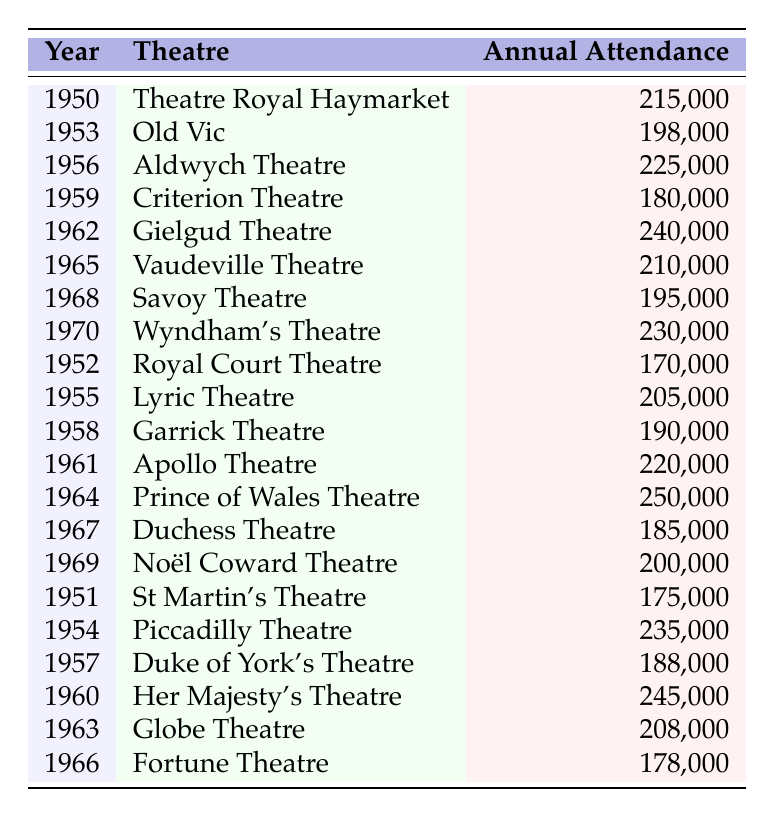What was the highest annual attendance recorded in the table? The highest annual attendance can be found by scanning through the values listed in the "Annual Attendance" column. The maximum value is 250,000 recorded for the Prince of Wales Theatre in 1964.
Answer: 250,000 In which year did the Aldwych Theatre have an annual attendance of 225,000? From the table, we can locate the entry for Aldwych Theatre and find that the annual attendance of 225,000 occurred in the year 1956.
Answer: 1956 What is the average annual attendance for the theaters listed in the table? First, we sum all the annual attendance figures: 215000 + 198000 + 225000 + 180000 + 240000 + 210000 + 195000 + 230000 + 170000 + 205000 + 190000 + 220000 + 250000 + 185000 + 200000 + 175000 + 235000 + 188000 + 245000 + 208000 + 178000 = 3,925,000. Next, we count the number of entries, which is 21. Finally, we divide the sum by the number of entries: 3,925,000 / 21 ≈ 186,904.76, rounding this gives approximately 186,905.
Answer: 186,905 Did the Royal Court Theatre have a higher attendance than the Lyric Theatre? We can compare their respective attendance figures: Royal Court Theatre had an attendance of 170,000, and the Lyric Theatre had 205,000. Since 170,000 is less than 205,000, the statement is false.
Answer: No Which theater had the lowest attendance in 1959? Checking the data for 1959, the Criterion Theatre had an attendance of 180,000, which is the only entry for that year, making it the lowest attendance figure in 1959.
Answer: Criterion Theatre What was the difference in annual attendance between the Gielgud Theatre and the Duchess Theatre? The Gielgud Theatre had an attendance of 240,000 and the Duchess Theatre had 185,000. To find the difference, subtract the lower figure from the higher: 240,000 - 185,000 = 55,000.
Answer: 55,000 Which years between 1950 and 1970 had an attendance figure greater than 200,000? We need to go through each entry from the table and identify those with attendance figures over 200,000. The valid years are 1956 (225,000), 1960 (245,000), 1961 (220,000), 1962 (240,000), 1964 (250,000), 1965 (210,000), 1970 (230,000).
Answer: 1956, 1960, 1961, 1962, 1964, 1965, 1970 How many theaters had an attendance below 190,000? By examining the attendance values, we find the following theaters below 190,000: Royal Court Theatre (170,000), St Martin's Theatre (175,000), Fortune Theatre (178,000), Duchess Theatre (185,000), and Criterion Theatre (180,000), totaling 5 theaters.
Answer: 5 Was the attendance for the theatres consistently increasing from 1950 to 1970? To determine this, we would need to review the annual figures for each year in order. There are several fluctuations such as an increase from 1950 to 1956, a decrease in 1959, and some ups and downs thereafter. Thus, attendance was not consistently increasing.
Answer: No What was the total attendance for the decade of the 1960s? We need to sum the numbers specifically for the entries in the 1960s: 245000 (1960) + 220000 (1961) + 208000 (1963) + 250000 (1964) + 210000 (1965) + 185000 (1967) + 200000 (1969) = 1,318,000.
Answer: 1,318,000 